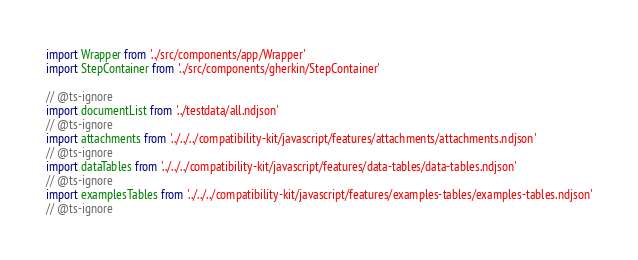<code> <loc_0><loc_0><loc_500><loc_500><_TypeScript_>import Wrapper from '../src/components/app/Wrapper'
import StepContainer from '../src/components/gherkin/StepContainer'

// @ts-ignore
import documentList from '../testdata/all.ndjson'
// @ts-ignore
import attachments from '../../../compatibility-kit/javascript/features/attachments/attachments.ndjson'
// @ts-ignore
import dataTables from '../../../compatibility-kit/javascript/features/data-tables/data-tables.ndjson'
// @ts-ignore
import examplesTables from '../../../compatibility-kit/javascript/features/examples-tables/examples-tables.ndjson'
// @ts-ignore</code> 